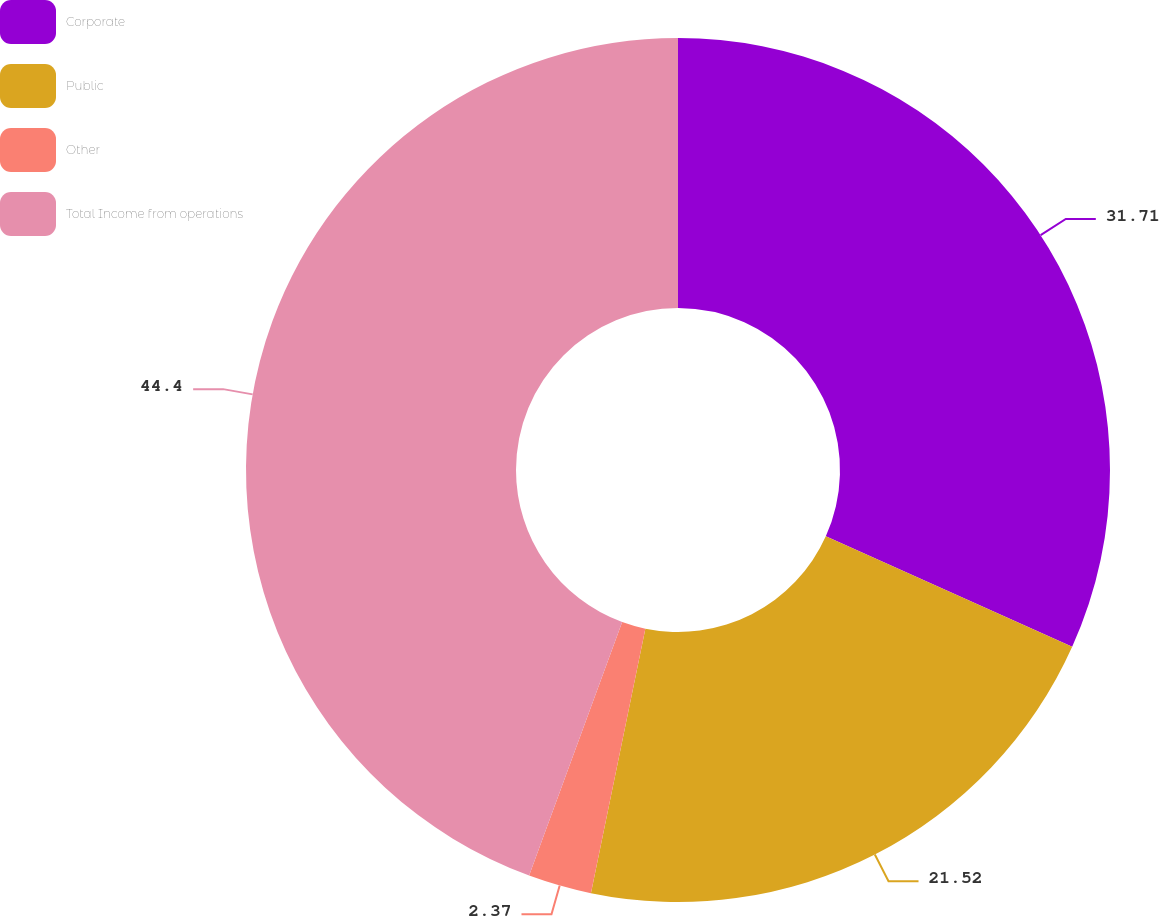Convert chart. <chart><loc_0><loc_0><loc_500><loc_500><pie_chart><fcel>Corporate<fcel>Public<fcel>Other<fcel>Total Income from operations<nl><fcel>31.71%<fcel>21.52%<fcel>2.37%<fcel>44.4%<nl></chart> 